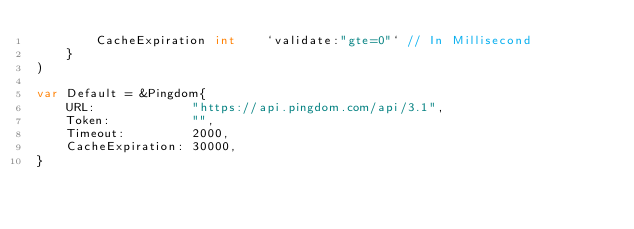Convert code to text. <code><loc_0><loc_0><loc_500><loc_500><_Go_>		CacheExpiration int    `validate:"gte=0"` // In Millisecond
	}
)

var Default = &Pingdom{
	URL:             "https://api.pingdom.com/api/3.1",
	Token:           "",
	Timeout:         2000,
	CacheExpiration: 30000,
}
</code> 